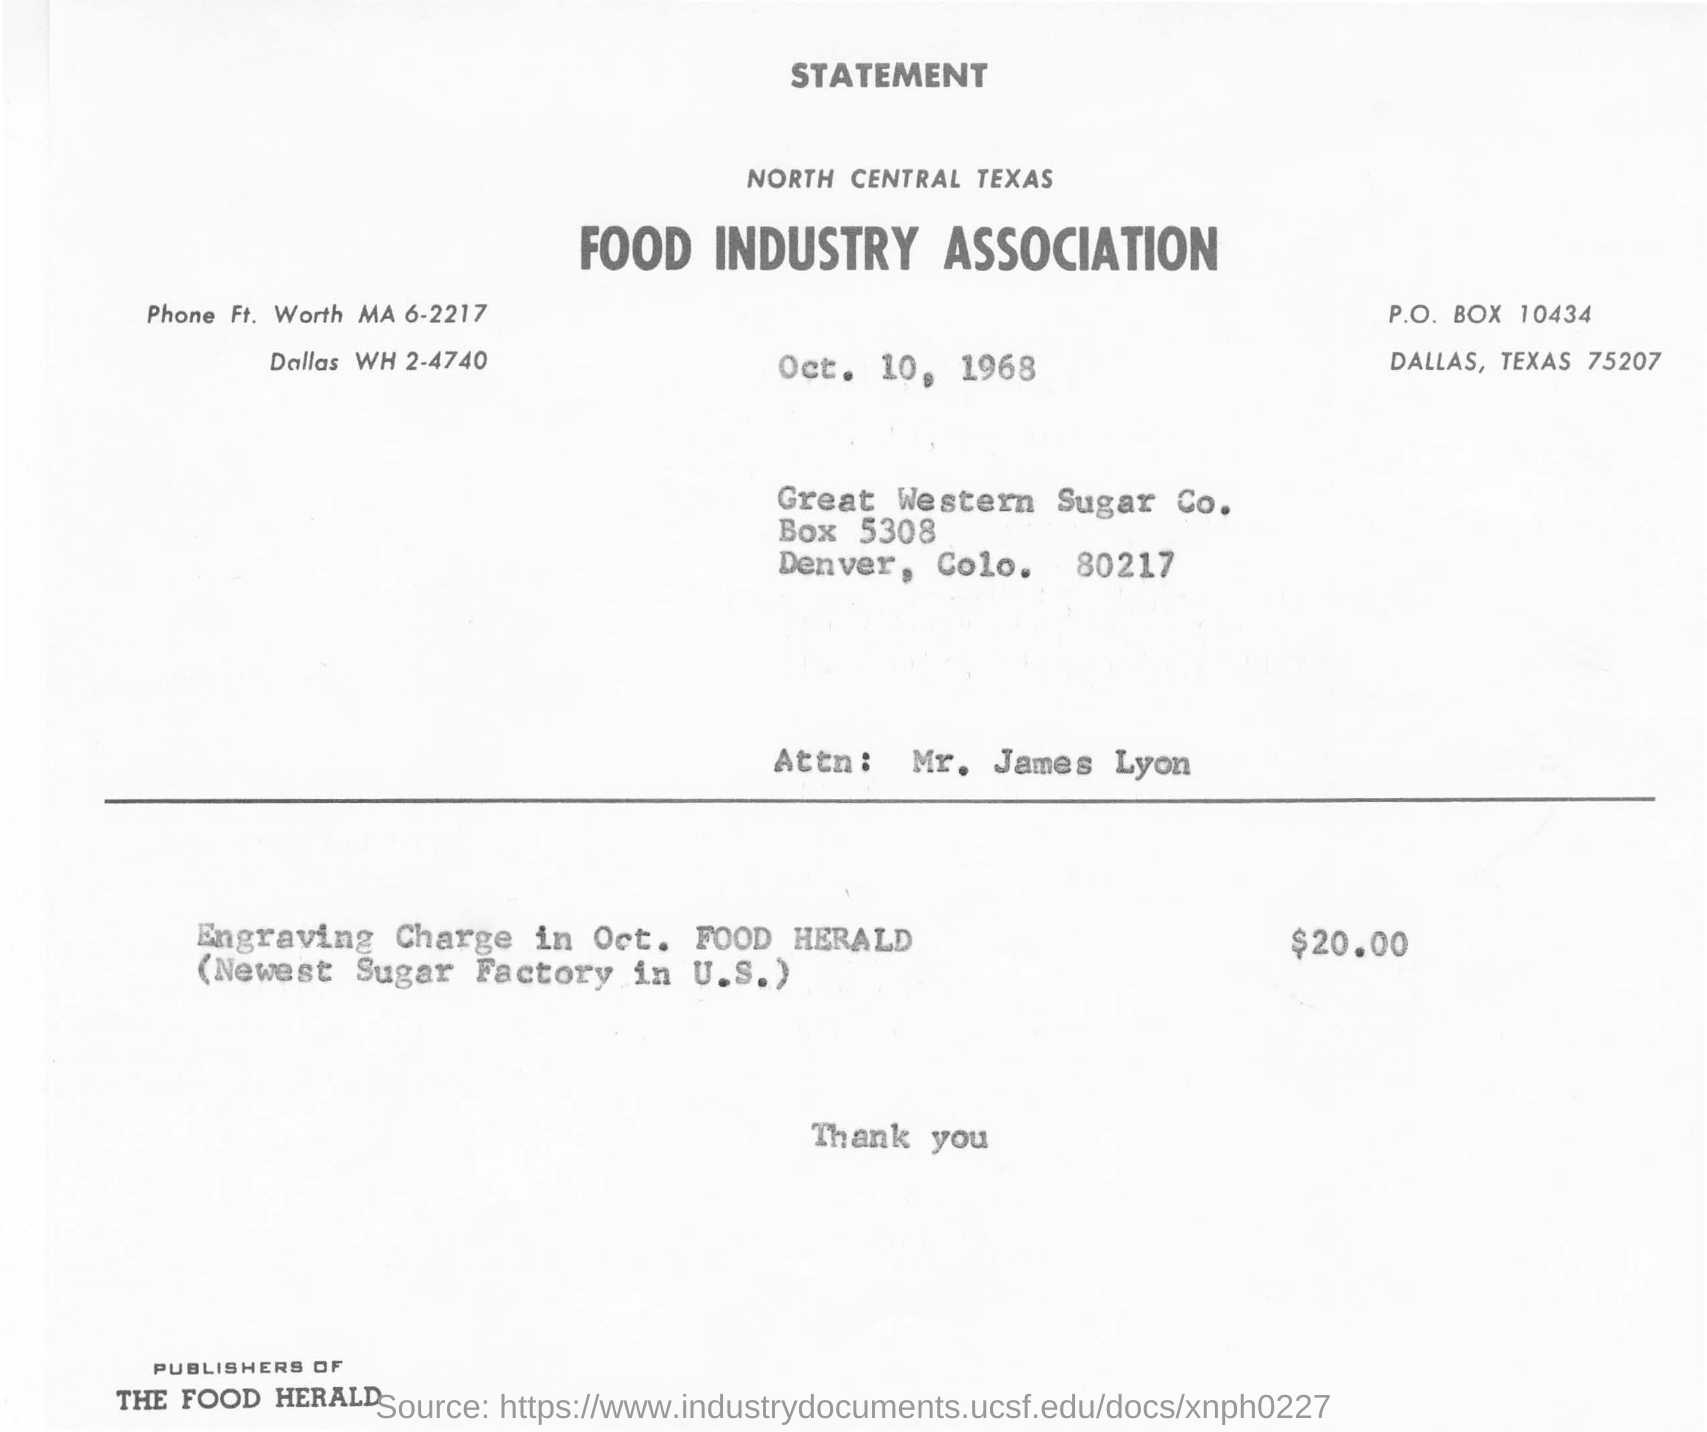List a handful of essential elements in this visual. The Food Herald is the publisher. The post box number for Dallas, Texas is 10434. On October 1st, in the Food Herald, there was an article about the cost of engraving money. The article stated that the charge for engraving was $20.00. The Texas Food Industry Association is located in the North Central zone. The name of the person in question is Mr. James Lyon. 